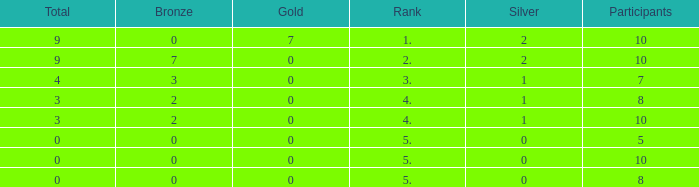What is listed as the highest Participants that also have a Rank of 5, and Silver that's smaller than 0? None. 